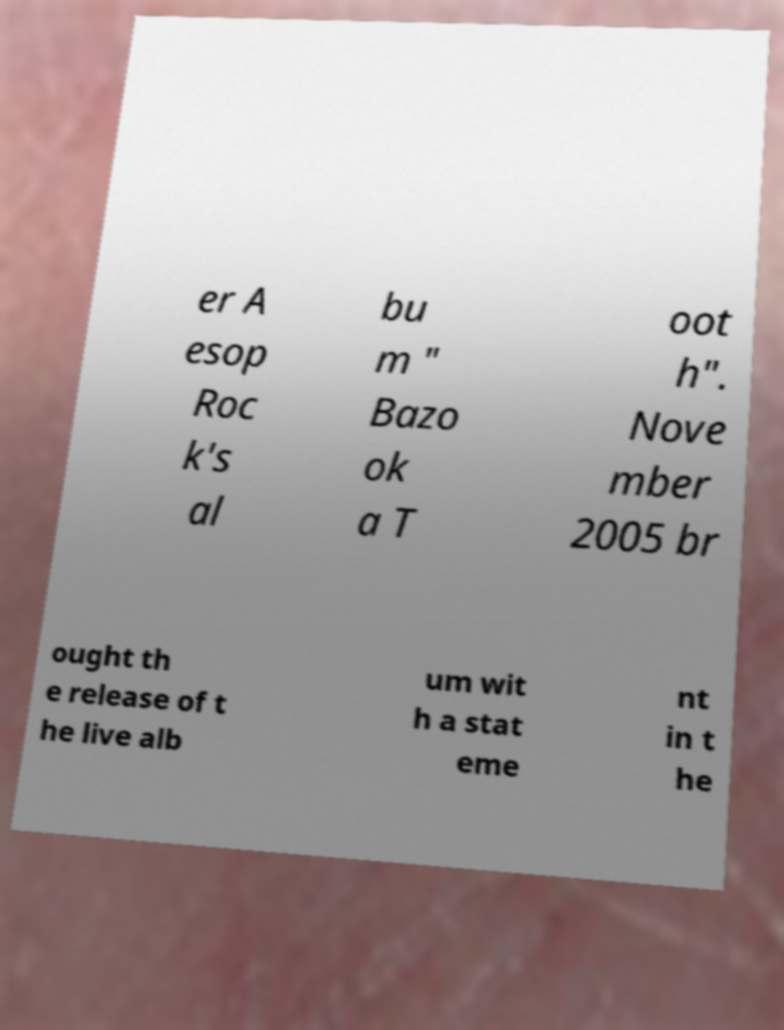Can you accurately transcribe the text from the provided image for me? er A esop Roc k's al bu m " Bazo ok a T oot h". Nove mber 2005 br ought th e release of t he live alb um wit h a stat eme nt in t he 